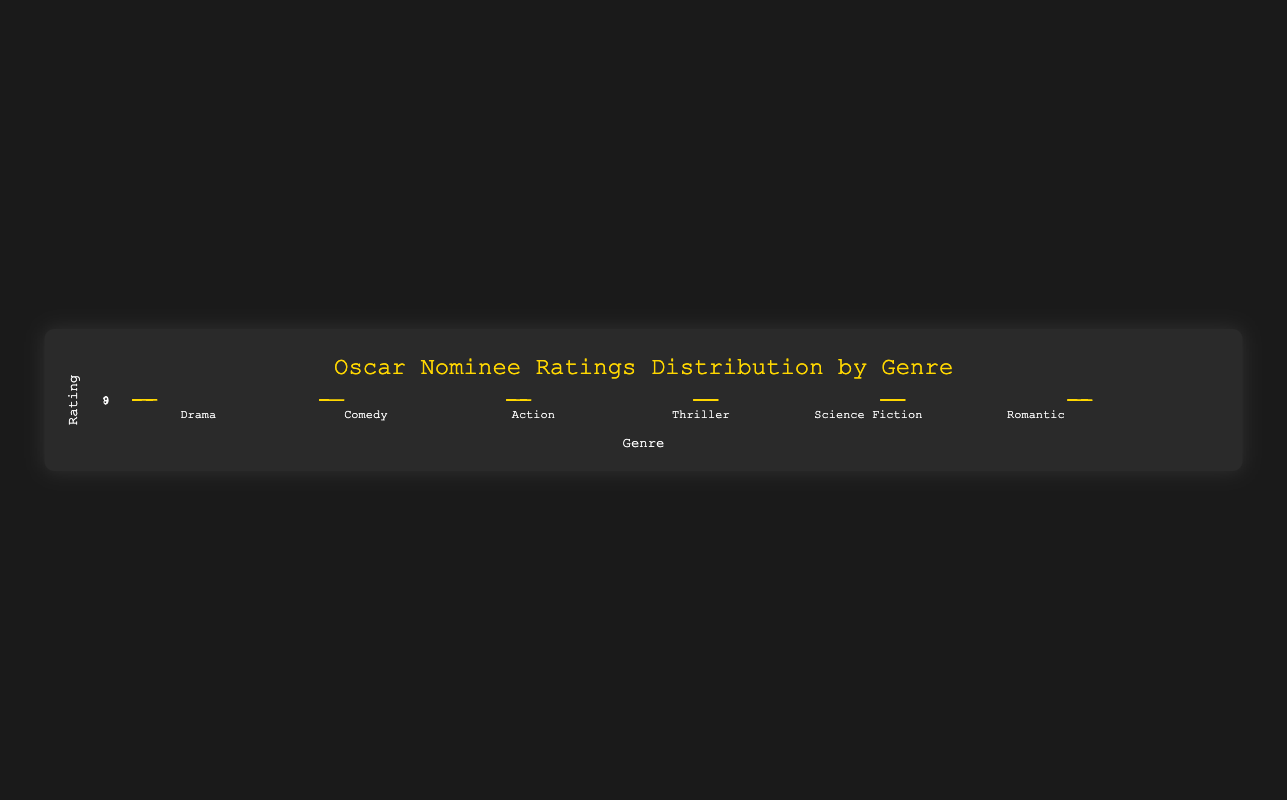Which genre has the highest median rating? Looking at the box plots, identify the genre where the median (central line in the box) is the highest among all the genres. The highest median appears in the Drama genre.
Answer: Drama Which genre has the lowest median rating? Identify the genre with the lowest median value (central line in the box). The lowest median is observed in the Comedy genre.
Answer: Comedy What's the range of ratings for the Science Fiction genre? The range is calculated by subtracting the minimum value from the maximum value within the Science Fiction box plot. The minimum rating is 8.0 and the maximum is 8.7. So, the range is 8.7 - 8.0.
Answer: 0.7 Which genre has the smallest interquartile range (IQR)? The IQR is the difference between the third quartile (Q3) and the first quartile (Q1). Compare the length of the boxes (IQR) for each genre, noting that the Comedy genre has the narrowest box.
Answer: Comedy What's the median rating for the Romantic genre? Find the central line inside the box plot for the Romantic genre, which represents the median rating. The median is at 7.85.
Answer: 7.85 Which genres have outliers? Identify any points that lie outside the whiskers of the box plots, which indicate outliers. In this case, there are no visible outliers in any of the box plots.
Answer: None How do the ratings for Drama compare to Comedy in terms of spread? Compare the length of the boxes and the whiskers in both the Drama and Comedy genres. Drama has a wider spread of ratings than Comedy, indicating more variability in ratings.
Answer: Drama has more spread Are there any genres where the ratings are closely clustered together? Look for genres with a smaller spread between the first and third quartiles and shorter whiskers. Comedy has ratings that are closely clustered together.
Answer: Comedy Which genre has the highest upper whisker value? Locate and compare the top ends of the whiskers for each genre. The upper whisker is highest for the Drama genre at 9.1.
Answer: Drama What is the interquartile range (IQR) for the Thriller genre? Calculate the IQR by subtracting the first quartile (Q1) from the third quartile (Q3). For Thriller, Q1 is approximately 8.0 and Q3 is approximately 8.4, so the IQR is 8.4 - 8.0.
Answer: 0.4 